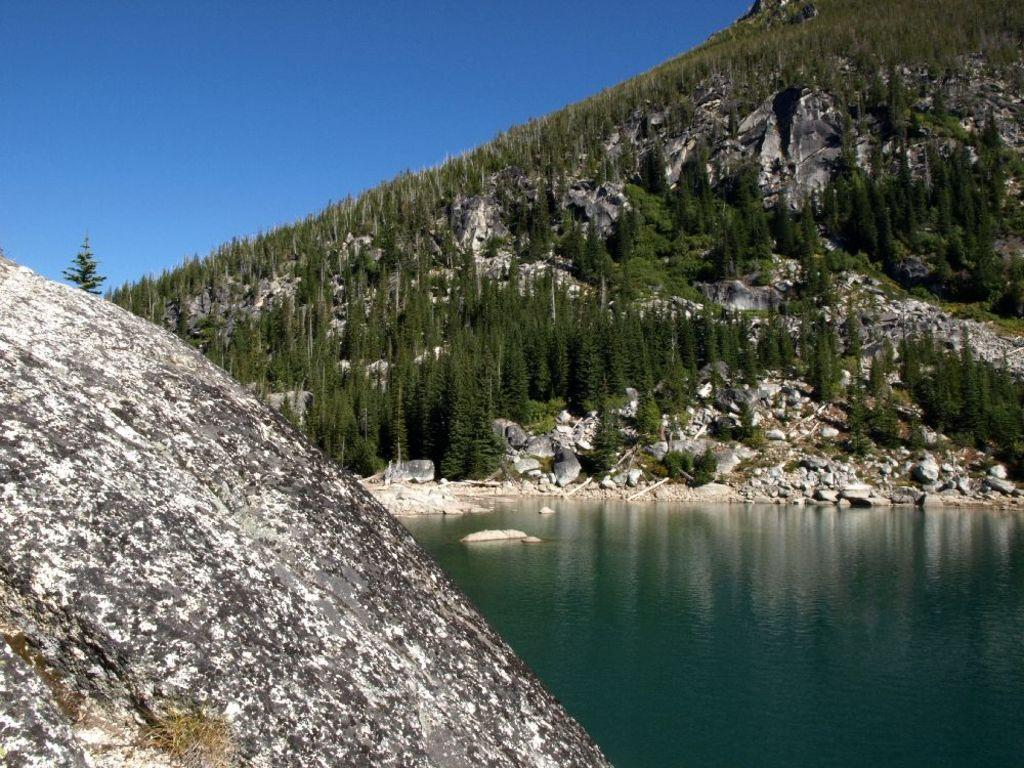What is the person holding in the image? The person is holding a cup of coffee in the image. What design can be seen on the cup? The cup has a design on it. What type of mine can be seen in the background of the image? There is no mine present in the image; it features a person holding a cup of coffee with a design on it. Can you tell me how many animals are visible in the zoo in the image? There is no zoo present in the image; it features a person holding a cup of coffee with a design on it. 